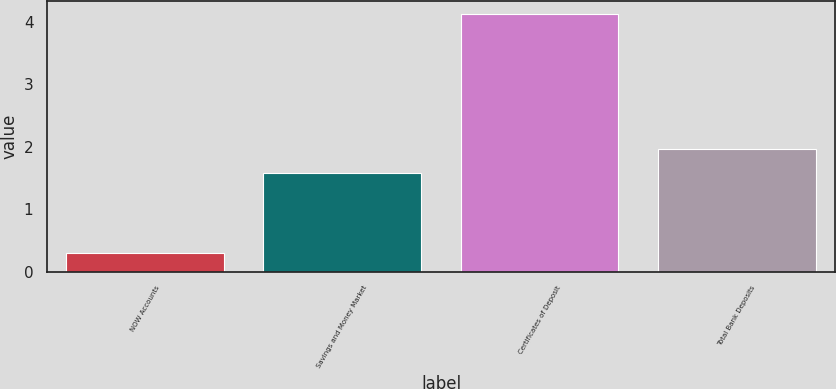Convert chart. <chart><loc_0><loc_0><loc_500><loc_500><bar_chart><fcel>NOW Accounts<fcel>Savings and Money Market<fcel>Certificates of Deposit<fcel>Total Bank Deposits<nl><fcel>0.3<fcel>1.58<fcel>4.12<fcel>1.96<nl></chart> 